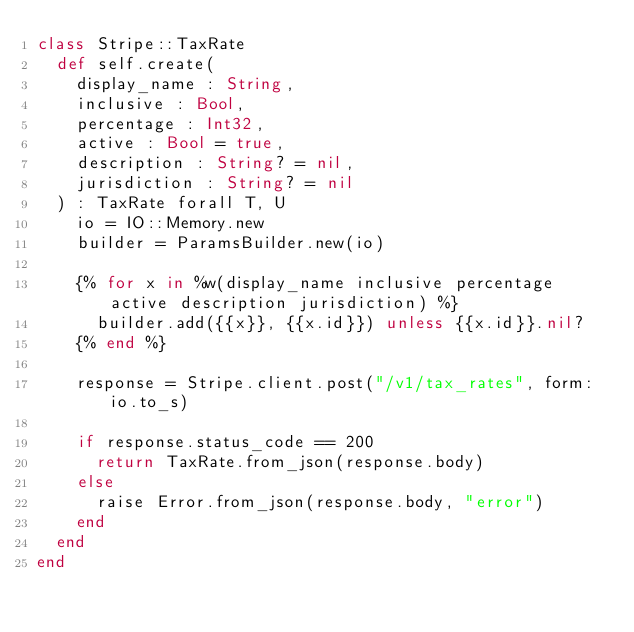<code> <loc_0><loc_0><loc_500><loc_500><_Crystal_>class Stripe::TaxRate
  def self.create(
    display_name : String,
    inclusive : Bool,
    percentage : Int32,
    active : Bool = true,
    description : String? = nil,
    jurisdiction : String? = nil
  ) : TaxRate forall T, U
    io = IO::Memory.new
    builder = ParamsBuilder.new(io)

    {% for x in %w(display_name inclusive percentage active description jurisdiction) %}
      builder.add({{x}}, {{x.id}}) unless {{x.id}}.nil?
    {% end %}

    response = Stripe.client.post("/v1/tax_rates", form: io.to_s)

    if response.status_code == 200
      return TaxRate.from_json(response.body)
    else
      raise Error.from_json(response.body, "error")
    end
  end
end
</code> 